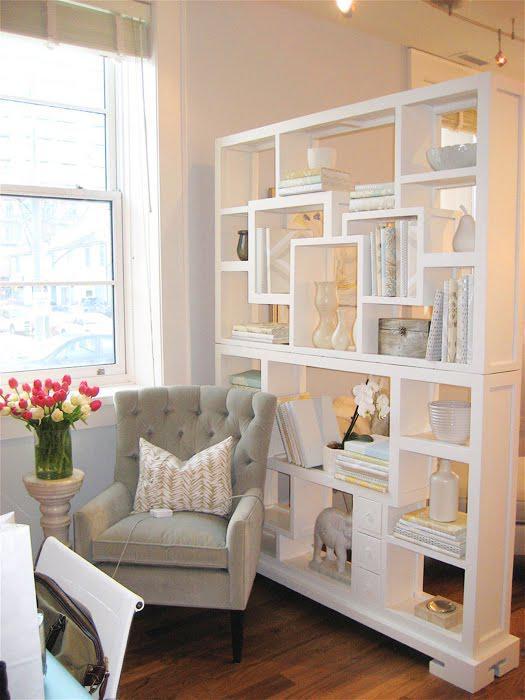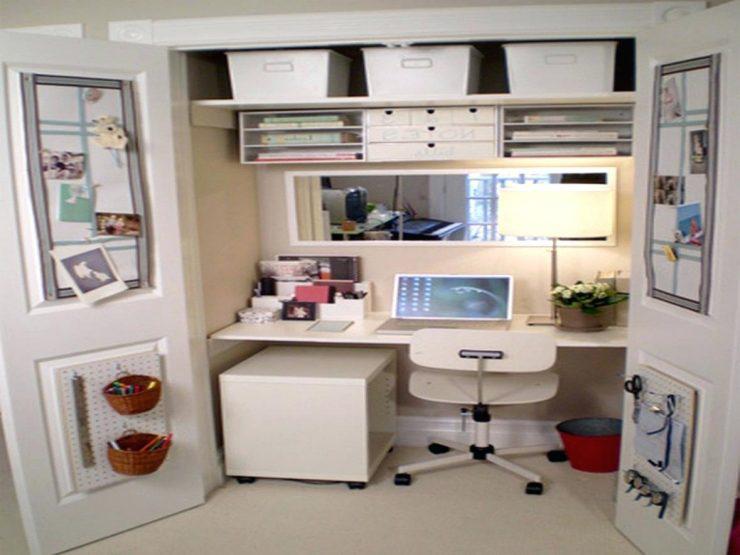The first image is the image on the left, the second image is the image on the right. Examine the images to the left and right. Is the description "In at least one image, there's a white shelf blocking a bed from view." accurate? Answer yes or no. No. 